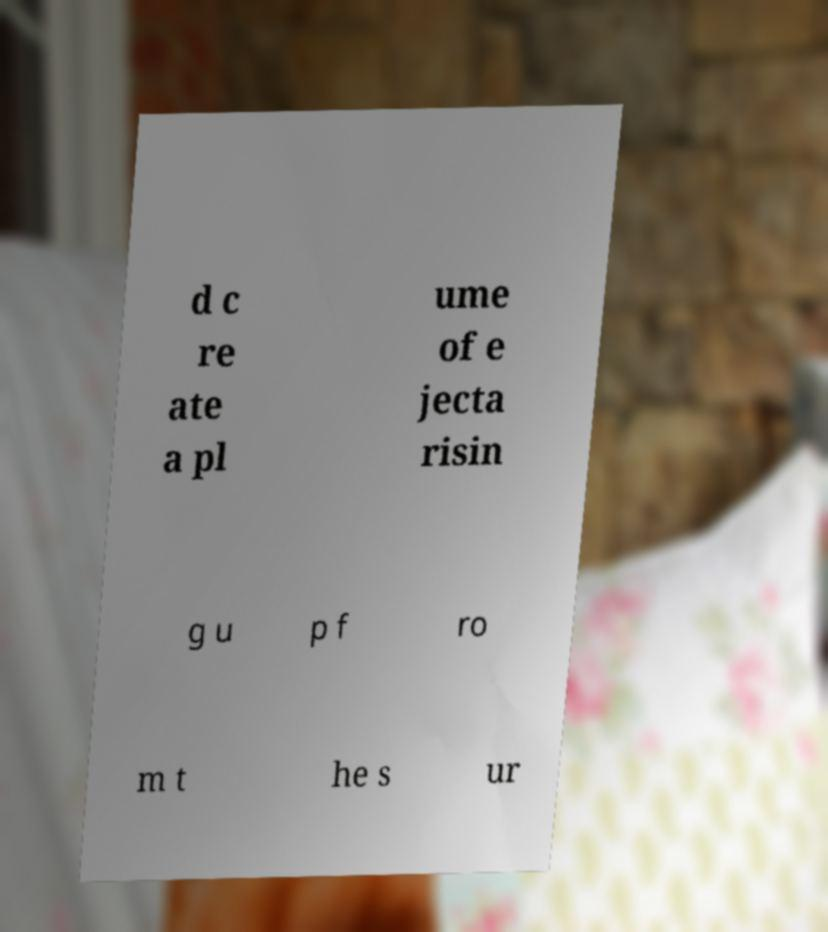For documentation purposes, I need the text within this image transcribed. Could you provide that? d c re ate a pl ume of e jecta risin g u p f ro m t he s ur 